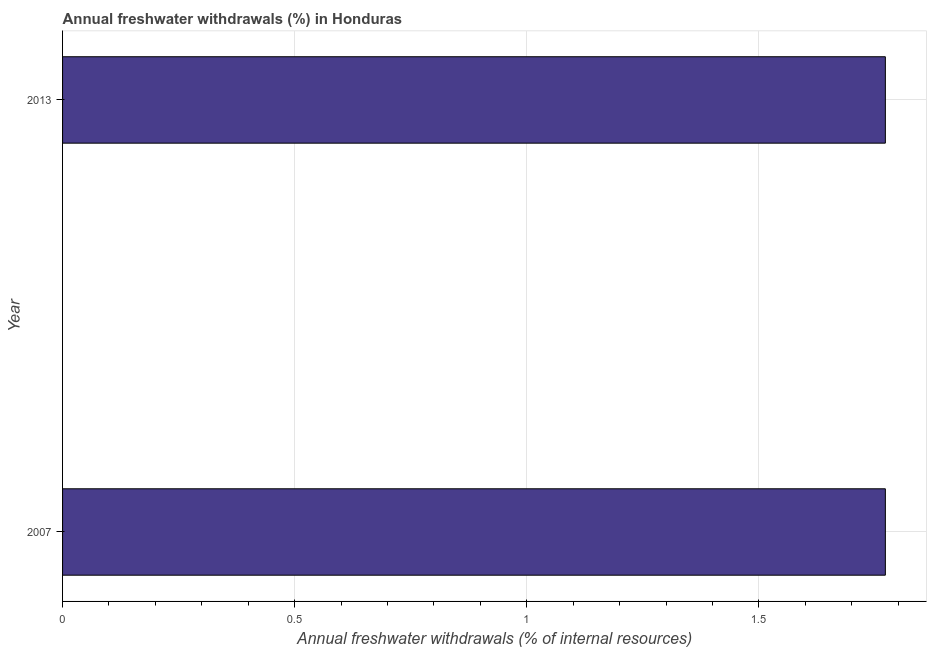Does the graph contain grids?
Provide a succinct answer. Yes. What is the title of the graph?
Your answer should be very brief. Annual freshwater withdrawals (%) in Honduras. What is the label or title of the X-axis?
Your response must be concise. Annual freshwater withdrawals (% of internal resources). What is the annual freshwater withdrawals in 2007?
Offer a terse response. 1.77. Across all years, what is the maximum annual freshwater withdrawals?
Ensure brevity in your answer.  1.77. Across all years, what is the minimum annual freshwater withdrawals?
Offer a very short reply. 1.77. In which year was the annual freshwater withdrawals maximum?
Offer a terse response. 2007. What is the sum of the annual freshwater withdrawals?
Provide a short and direct response. 3.55. What is the average annual freshwater withdrawals per year?
Your answer should be compact. 1.77. What is the median annual freshwater withdrawals?
Ensure brevity in your answer.  1.77. In how many years, is the annual freshwater withdrawals greater than 0.8 %?
Make the answer very short. 2. Do a majority of the years between 2007 and 2013 (inclusive) have annual freshwater withdrawals greater than 1.7 %?
Provide a short and direct response. Yes. Is the annual freshwater withdrawals in 2007 less than that in 2013?
Offer a terse response. No. How many years are there in the graph?
Provide a succinct answer. 2. Are the values on the major ticks of X-axis written in scientific E-notation?
Provide a succinct answer. No. What is the Annual freshwater withdrawals (% of internal resources) in 2007?
Give a very brief answer. 1.77. What is the Annual freshwater withdrawals (% of internal resources) in 2013?
Make the answer very short. 1.77. 